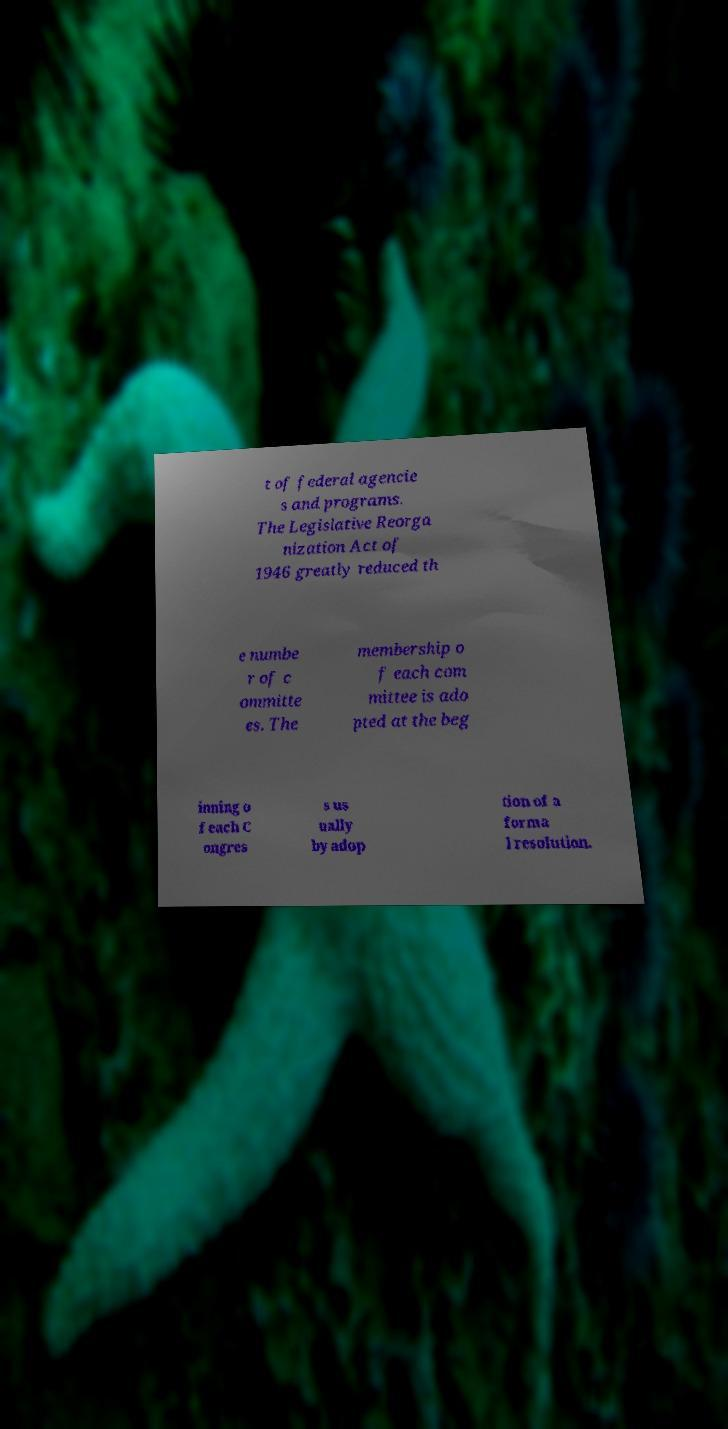Could you extract and type out the text from this image? t of federal agencie s and programs. The Legislative Reorga nization Act of 1946 greatly reduced th e numbe r of c ommitte es. The membership o f each com mittee is ado pted at the beg inning o f each C ongres s us ually by adop tion of a forma l resolution. 